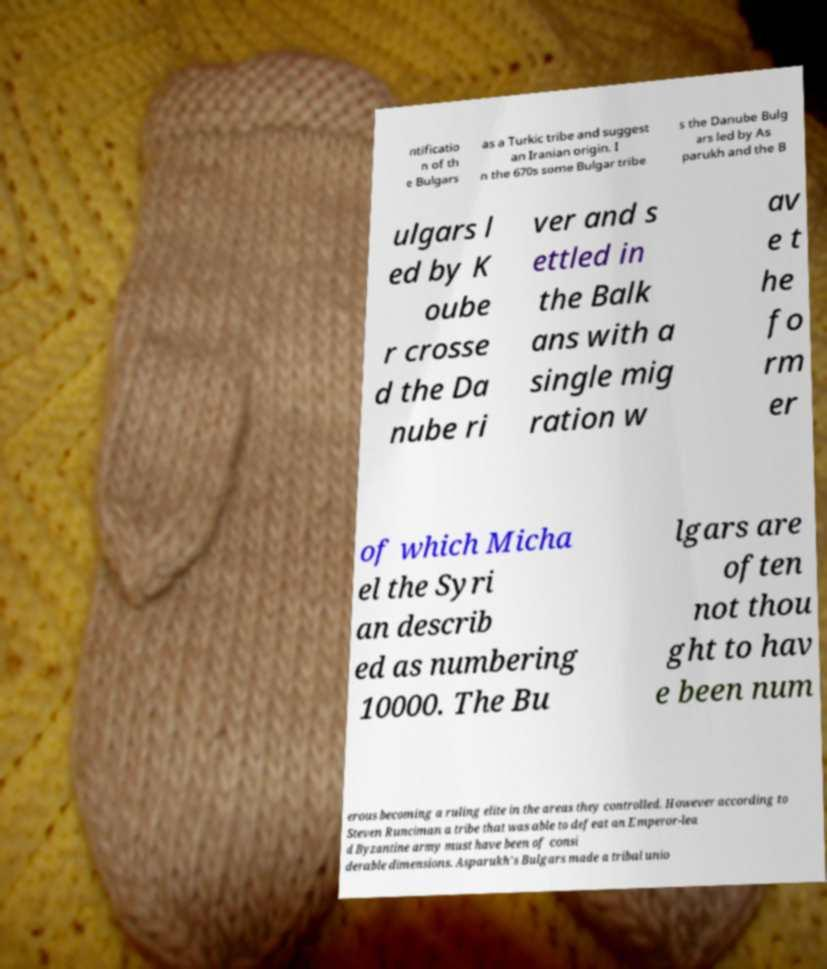For documentation purposes, I need the text within this image transcribed. Could you provide that? ntificatio n of th e Bulgars as a Turkic tribe and suggest an Iranian origin. I n the 670s some Bulgar tribe s the Danube Bulg ars led by As parukh and the B ulgars l ed by K oube r crosse d the Da nube ri ver and s ettled in the Balk ans with a single mig ration w av e t he fo rm er of which Micha el the Syri an describ ed as numbering 10000. The Bu lgars are often not thou ght to hav e been num erous becoming a ruling elite in the areas they controlled. However according to Steven Runciman a tribe that was able to defeat an Emperor-lea d Byzantine army must have been of consi derable dimensions. Asparukh's Bulgars made a tribal unio 